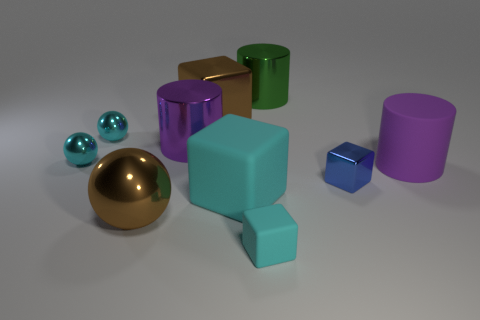What number of other things are the same shape as the green object?
Make the answer very short. 2. How many big brown metal objects are right of the large green cylinder?
Make the answer very short. 0. There is a purple shiny cylinder behind the blue cube; is it the same size as the purple object right of the green cylinder?
Your answer should be compact. Yes. How many other things are there of the same size as the green metallic cylinder?
Give a very brief answer. 5. What material is the big cylinder that is on the left side of the big cyan cube that is left of the purple object that is right of the big green cylinder made of?
Your answer should be compact. Metal. Do the green metal cylinder and the brown metallic object that is in front of the matte cylinder have the same size?
Give a very brief answer. Yes. How big is the cyan thing that is behind the small matte thing and in front of the rubber cylinder?
Provide a short and direct response. Large. Are there any shiny things that have the same color as the rubber cylinder?
Provide a succinct answer. Yes. There is a big metallic thing that is in front of the blue metallic object behind the small cyan rubber block; what is its color?
Provide a short and direct response. Brown. Are there fewer small cyan matte things on the right side of the tiny blue metallic cube than cyan rubber things that are on the right side of the large cyan thing?
Provide a short and direct response. Yes. 